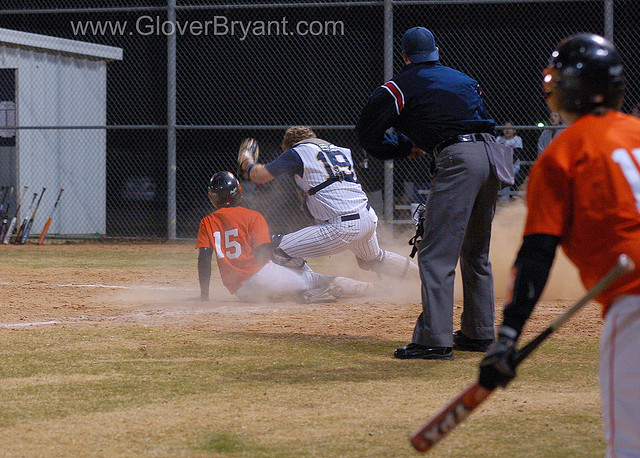Please extract the text content from this image. www.GloverBryant.com 15 